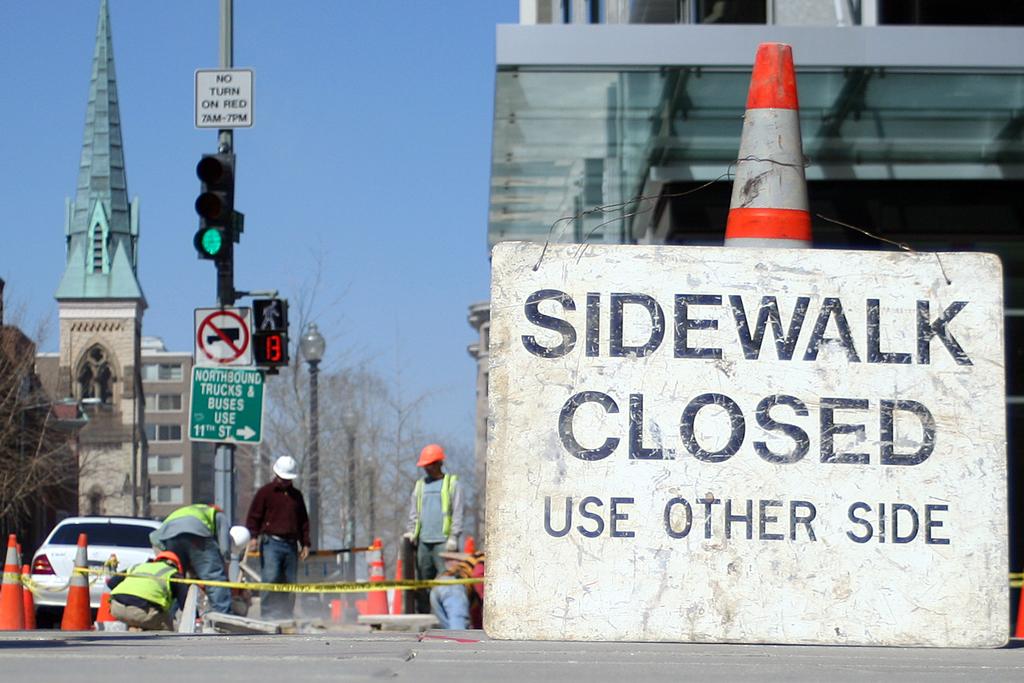What street sign is on the traffic light pole?
Keep it short and to the point. No turn on red 7am-7pm. 